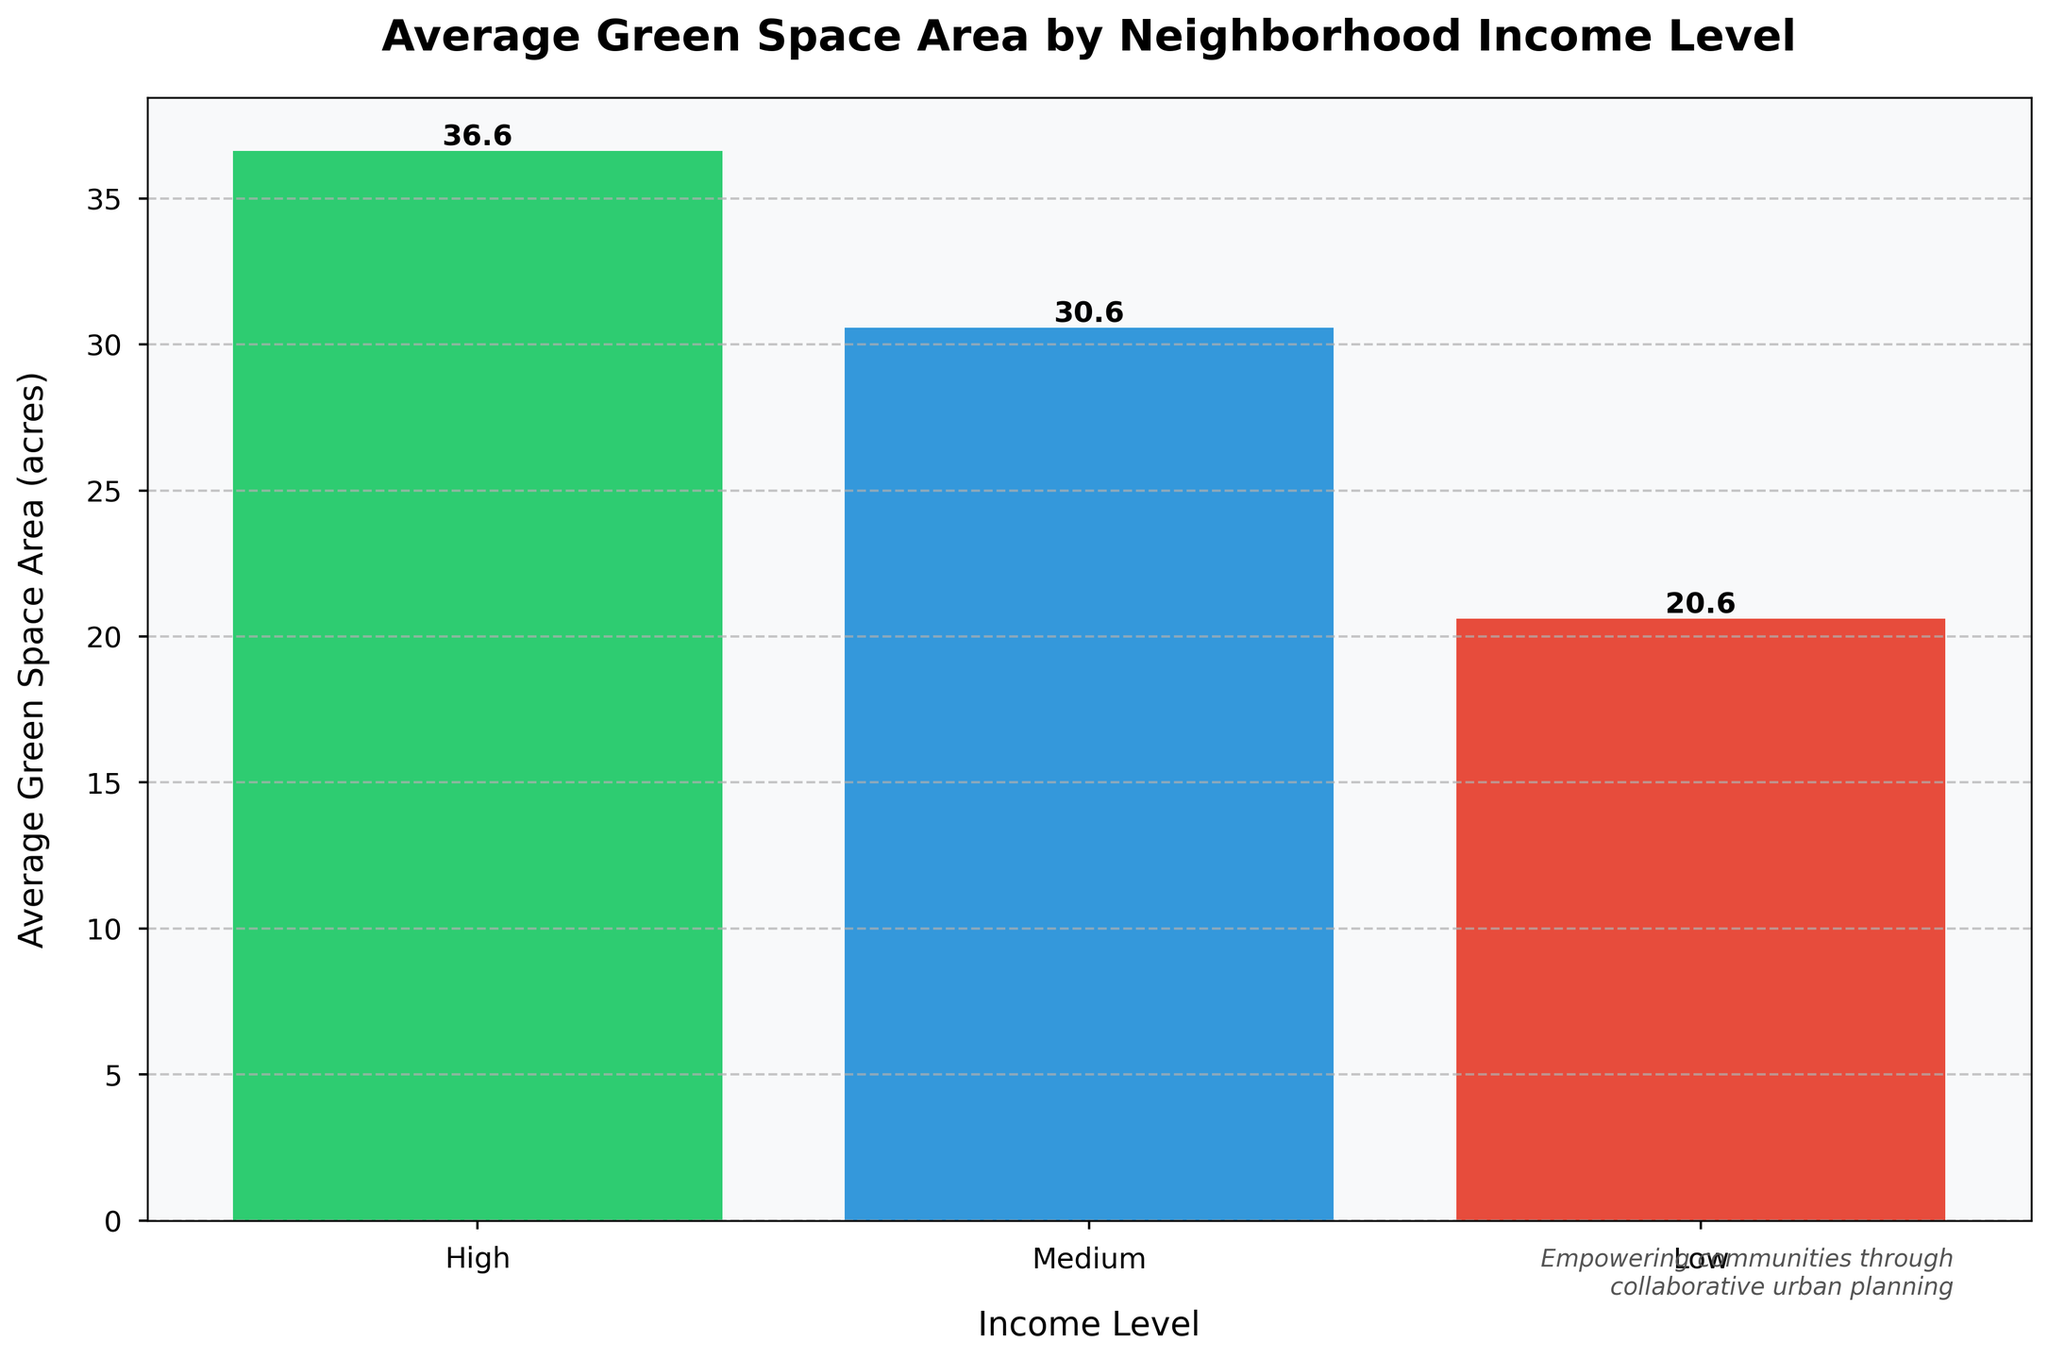What's the average green space area in high-income neighborhoods? The visual graph shows high-income neighborhoods with green space areas. Averaging the values of 42.3, 35.7, 48.9, and 19.6: (42.3 + 35.7 + 48.9 + 19.6) / 4 = 36.625 acres
Answer: 36.6 acres Which income level has the highest average green space area? By looking at the bar heights, it is clear that high, medium, and low income levels have different average green space areas. The tallest bar represents medium income levels, indicating the highest average green space area among them.
Answer: Medium How much more green space area is there on average in medium-income neighborhoods compared to low-income neighborhoods? From the bar heights, medium-income neighborhoods have a green space area of 30.56 acres and low-income neighborhoods have 20.62 acres. The difference is: 30.56 - 20.62 = 9.94 acres
Answer: 9.94 acres What's the difference between the highest and the lowest average green space area? The highest green space area corresponds to medium-income neighborhoods at 30.56 acres, and the lowest corresponds to low-income neighborhoods at 20.62 acres. The difference is: 30.56 - 20.62 = 9.94 acres
Answer: 9.94 acres What's the average green space area for each income level, ranked from highest to lowest? The bars indicate different green space areas: Medium (30.56 acres), High (36.625 acres), and Low (20.62 acres). The decreasing order is High (36.625), Medium (30.56), Low (20.62)
Answer: High (36.625), Medium (30.56), Low (20.62) How does the bar color indicate different income levels? The color of the bars helps categorize different income levels: green, blue, and red represent high, medium, and low-income levels, respectively.
Answer: Green: high, Blue: medium, Red: low 